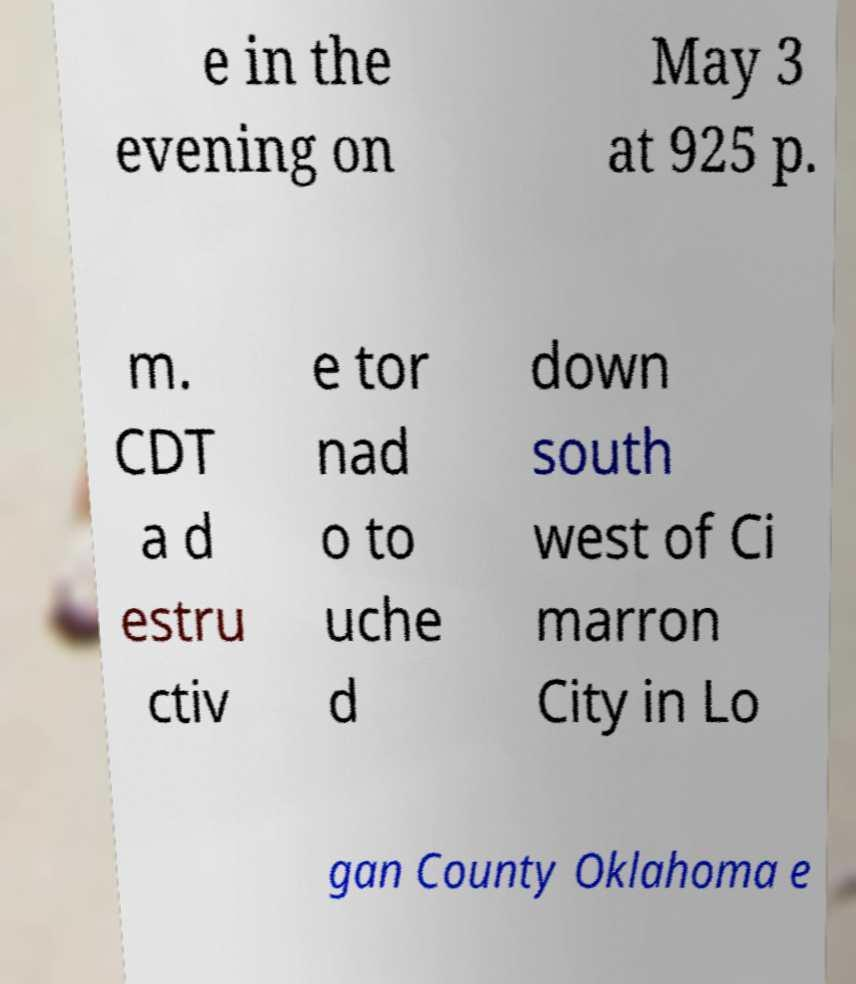Could you extract and type out the text from this image? e in the evening on May 3 at 925 p. m. CDT a d estru ctiv e tor nad o to uche d down south west of Ci marron City in Lo gan County Oklahoma e 